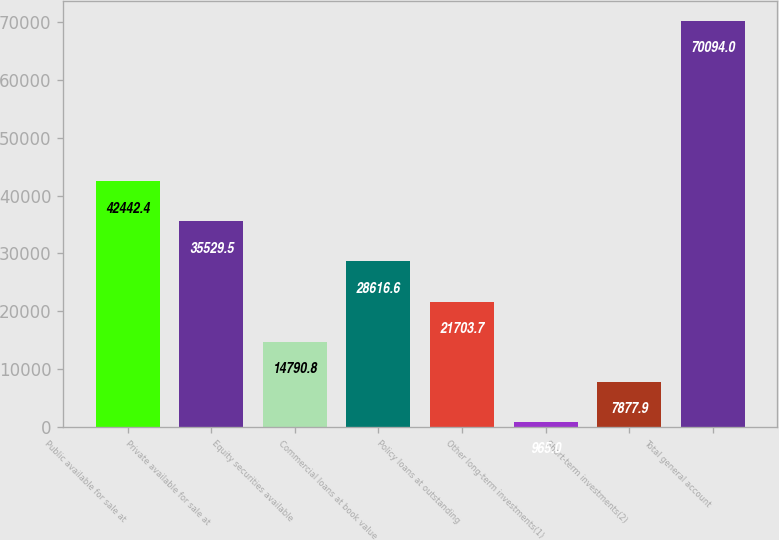Convert chart to OTSL. <chart><loc_0><loc_0><loc_500><loc_500><bar_chart><fcel>Public available for sale at<fcel>Private available for sale at<fcel>Equity securities available<fcel>Commercial loans at book value<fcel>Policy loans at outstanding<fcel>Other long-term investments(1)<fcel>Short-term investments(2)<fcel>Total general account<nl><fcel>42442.4<fcel>35529.5<fcel>14790.8<fcel>28616.6<fcel>21703.7<fcel>965<fcel>7877.9<fcel>70094<nl></chart> 